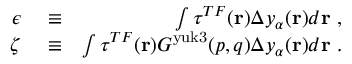Convert formula to latex. <formula><loc_0><loc_0><loc_500><loc_500>\begin{array} { r l r } { \epsilon } & \equiv } & { \int \tau ^ { T F } ( r ) \Delta y _ { \alpha } ( r ) d r \ , } \\ { \zeta } & \equiv } & { \int \tau ^ { T F } ( r ) G ^ { y u k 3 } ( p , q ) \Delta y _ { \alpha } ( r ) d r \ . } \end{array}</formula> 